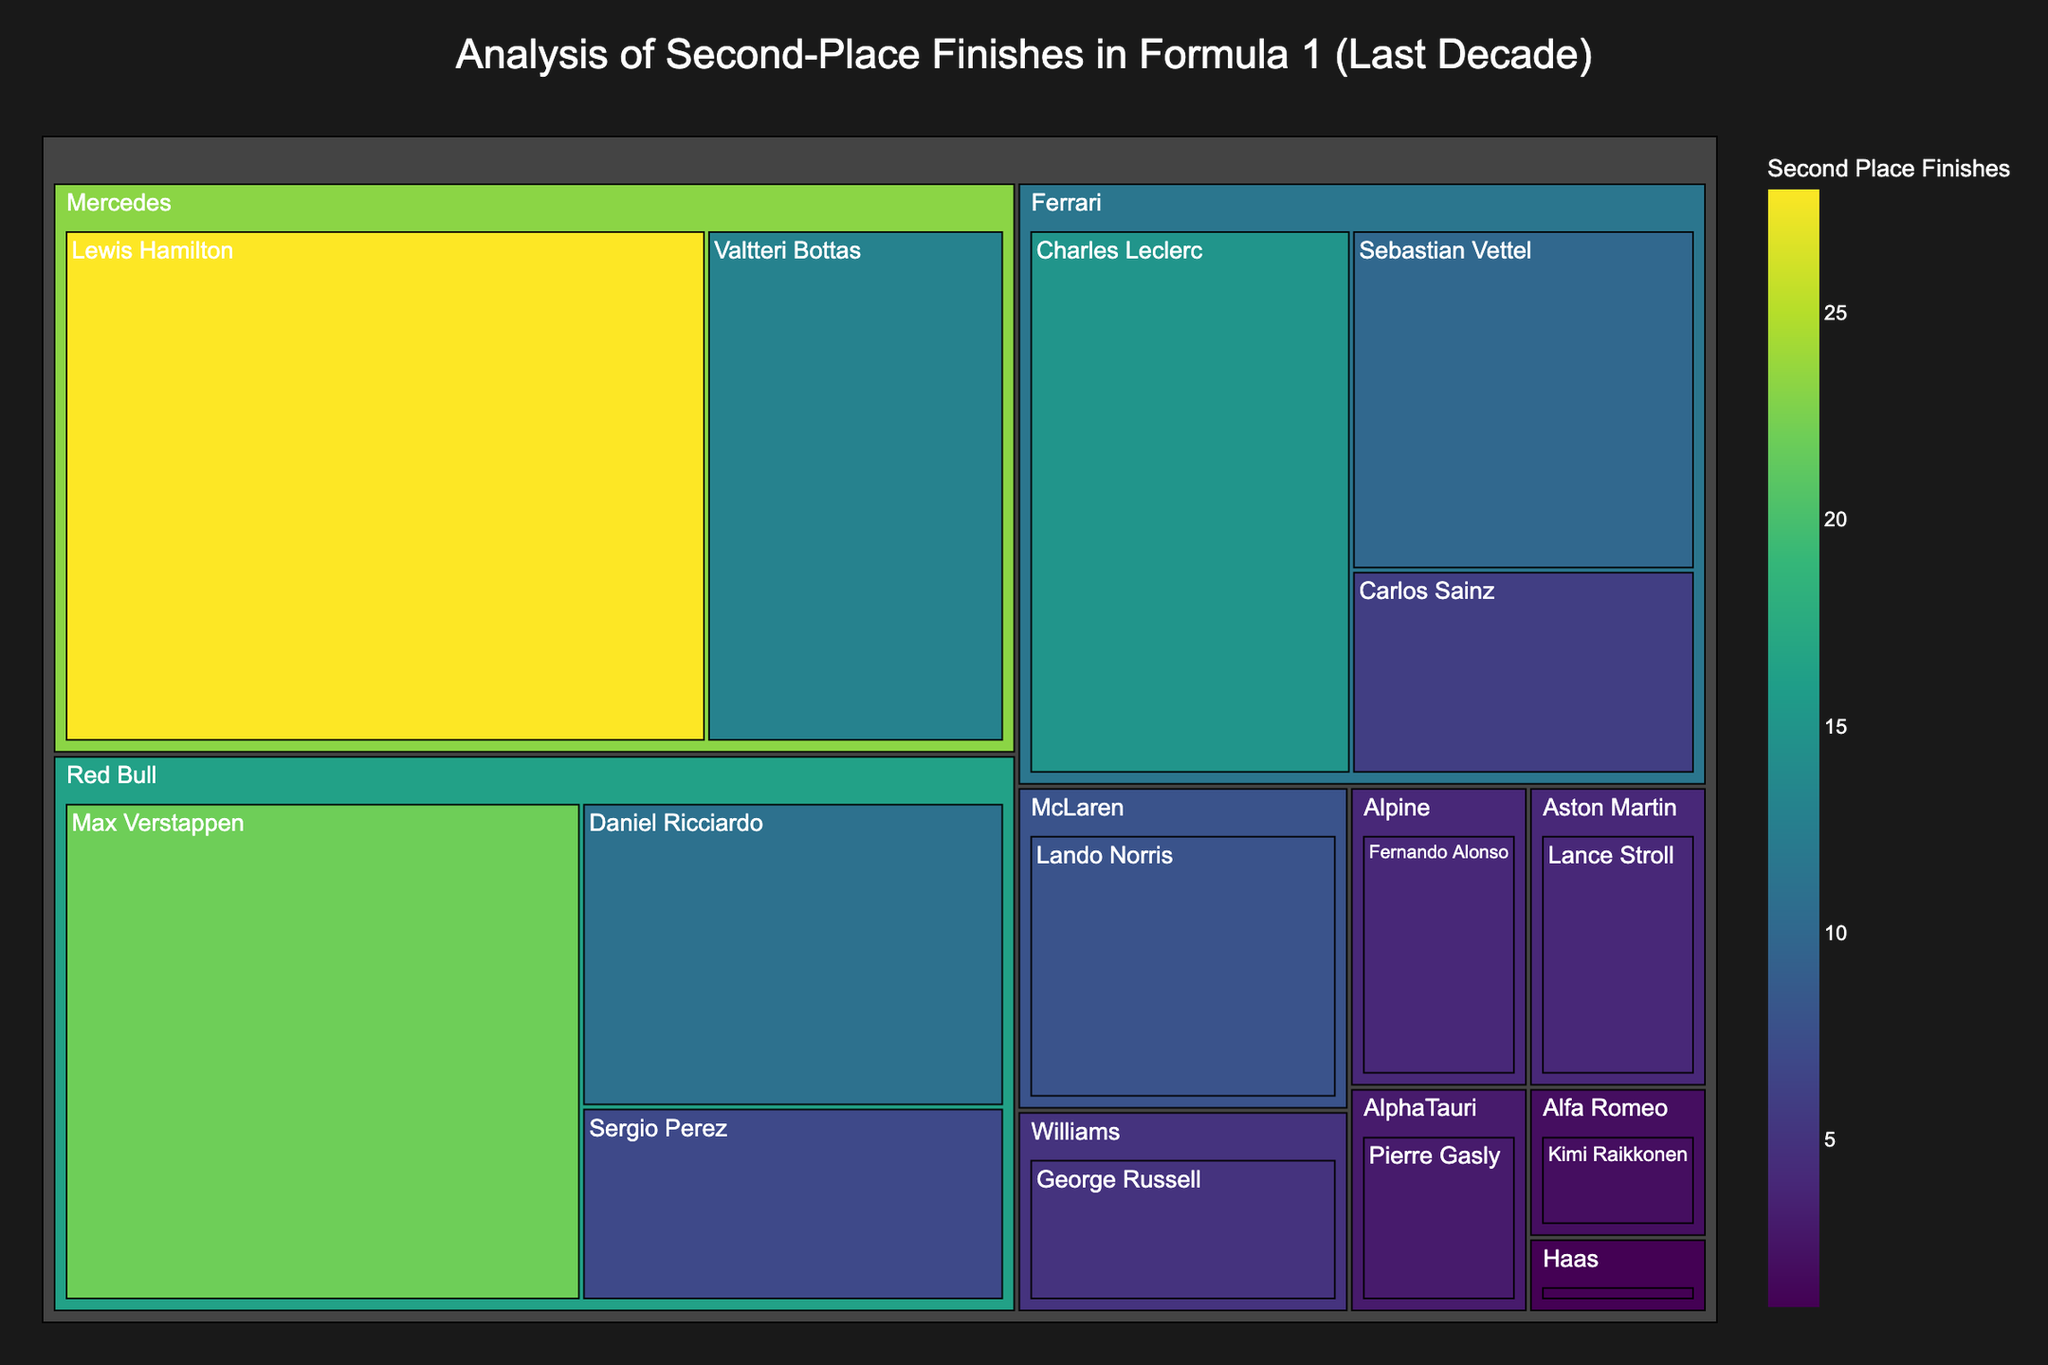What's the title of the treemap? The title of the treemap is usually displayed at the top of the figure.
Answer: Analysis of Second-Place Finishes in Formula 1 (Last Decade) Which driver has the highest number of second-place finishes? Identify the largest block in the treemap, which corresponds to the driver with the highest number of second-place finishes.
Answer: Lewis Hamilton How many second-place finishes does Max Verstappen have? Look at the block labeled "Max Verstappen" to find the value.
Answer: 22 Compare the number of second-place finishes between Ferrari's Charles Leclerc and Mercedes' Valtteri Bottas. Who has more? Identify the blocks for "Charles Leclerc" and "Valtteri Bottas" and compare their values.
Answer: Charles Leclerc What's the total number of second-place finishes for Ferrari drivers? Sum the second-place finishes for all Ferrari drivers: Charles Leclerc, Sebastian Vettel, and Carlos Sainz (15 + 10 + 6).
Answer: 31 Which team has the most second-place finishes in total and how many do they have? Add up the second-place finishes for each team's drivers and compare the totals to find the team with the most.
Answer: Mercedes with 41 How many teams have more than 10 second-place finishes? Count the number of distinct teams whose combined driver total for second-place finishes exceeds 10.
Answer: Three (Mercedes, Red Bull, Ferrari) What percentage of total second-place finishes did Red Bull drivers achieve? Calculate the total second-place finishes for Red Bull drivers and divide by the grand total of all second-place finishes, then multiply by 100. Red Bull: 22 + 11 + 7. Grand Total: 28 + 22 + 15 + 13 + 11 + 10 + 8 + 7 + 6 + 5 + 4 + 4 + 3 + 2 + 1. (40 / 139) * 100.
Answer: 28.8% How does the second-place record of Daniel Ricciardo compare to Sergio Perez within Red Bull? Identify the blocks for "Daniel Ricciardo" and "Sergio Perez" under the "Red Bull" section and compare their values.
Answer: Daniel Ricciardo has more Which driver from the McLaren team has second-place finishes, and how many? Locate the "McLaren" block and then look inside it to find the driver and their number of second-place finishes.
Answer: Lando Norris with 8 